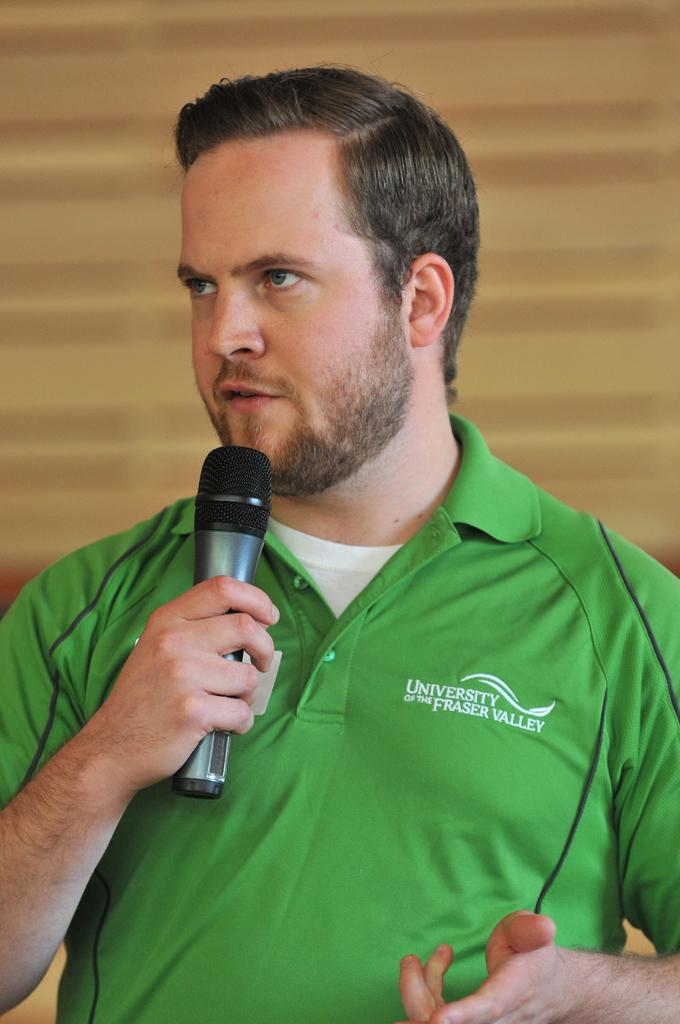Who is the main subject in the image? There is a boy in the image. Where is the boy positioned in the image? The boy is at the center of the image. What is the boy holding in his hand? The boy is holding a mic in his hand. What color is the rabbit's eye in the image? There is no rabbit present in the image, so it is not possible to answer that question. 